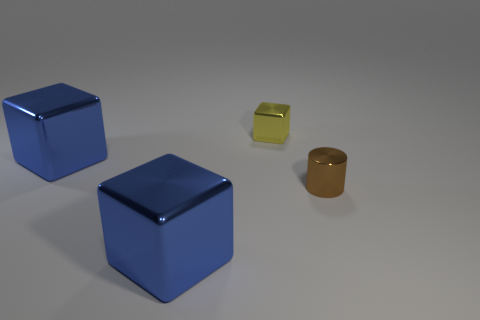Is the small object behind the tiny brown thing made of the same material as the big cube behind the metallic cylinder?
Keep it short and to the point. Yes. What is the material of the yellow block?
Give a very brief answer. Metal. Is the number of yellow shiny blocks behind the small brown thing greater than the number of small yellow metal blocks?
Your answer should be compact. No. How many blue metallic cubes are behind the tiny yellow metallic object that is behind the metal object on the right side of the yellow metal cube?
Make the answer very short. 0. The thing that is both in front of the tiny cube and behind the small brown shiny thing is made of what material?
Make the answer very short. Metal. What color is the metal cylinder?
Give a very brief answer. Brown. Are there more small brown metallic cylinders to the right of the small yellow shiny block than blue metal blocks in front of the tiny cylinder?
Offer a very short reply. No. There is a tiny thing to the right of the yellow metal thing; what is its color?
Offer a terse response. Brown. Do the blue shiny block that is behind the brown metal cylinder and the thing that is in front of the tiny brown metal cylinder have the same size?
Provide a succinct answer. Yes. How many objects are blue shiny blocks or small yellow metal objects?
Your response must be concise. 3. 